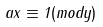<formula> <loc_0><loc_0><loc_500><loc_500>a x \equiv 1 ( m o d y )</formula> 